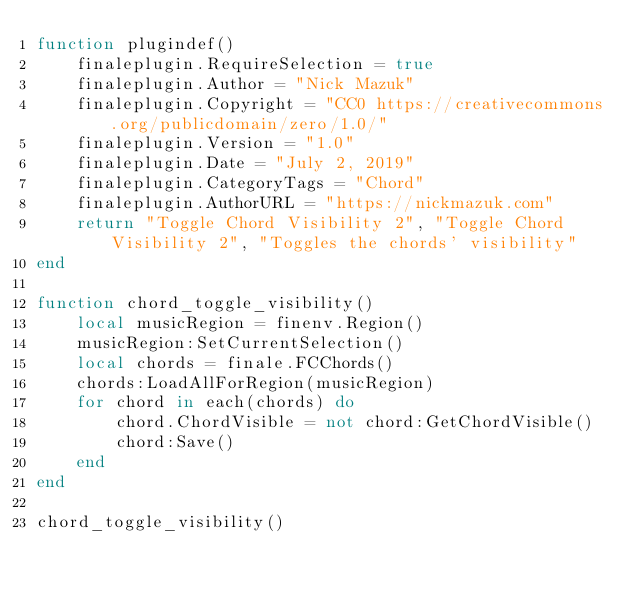<code> <loc_0><loc_0><loc_500><loc_500><_Lua_>function plugindef()
    finaleplugin.RequireSelection = true
    finaleplugin.Author = "Nick Mazuk"
    finaleplugin.Copyright = "CC0 https://creativecommons.org/publicdomain/zero/1.0/"
    finaleplugin.Version = "1.0"
    finaleplugin.Date = "July 2, 2019"
    finaleplugin.CategoryTags = "Chord"
    finaleplugin.AuthorURL = "https://nickmazuk.com"
    return "Toggle Chord Visibility 2", "Toggle Chord Visibility 2", "Toggles the chords' visibility"
end

function chord_toggle_visibility()
    local musicRegion = finenv.Region()
    musicRegion:SetCurrentSelection()
    local chords = finale.FCChords()
    chords:LoadAllForRegion(musicRegion)
    for chord in each(chords) do
        chord.ChordVisible = not chord:GetChordVisible()
        chord:Save()
    end
end

chord_toggle_visibility()
</code> 